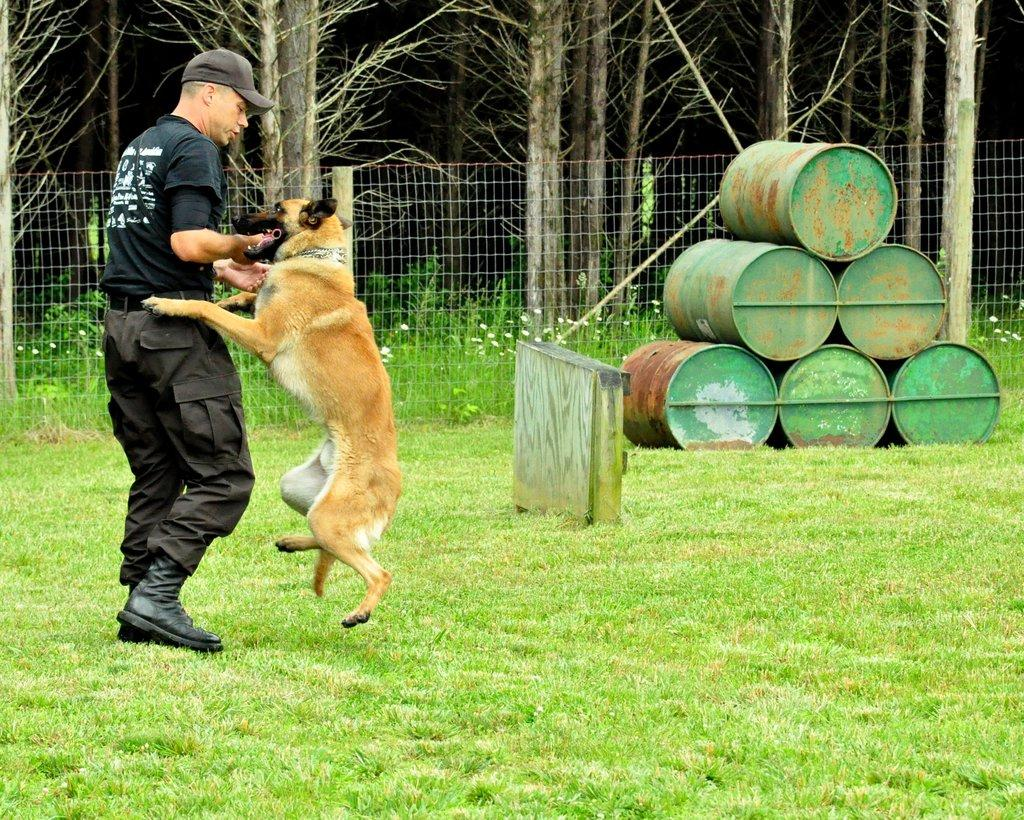What is present in the image along with the man? There is a dog in the image. What is the position of the man and the dog in the image? Both the man and the dog are standing on the ground. What can be seen in the background of the image? There are drums, fencing, and trees in the background of the image. What type of root can be seen growing from the man's head in the image? There is no root growing from the man's head in the image. What time of day is depicted in the image? The provided facts do not give any information about the time of day, so it cannot be determined from the image. 